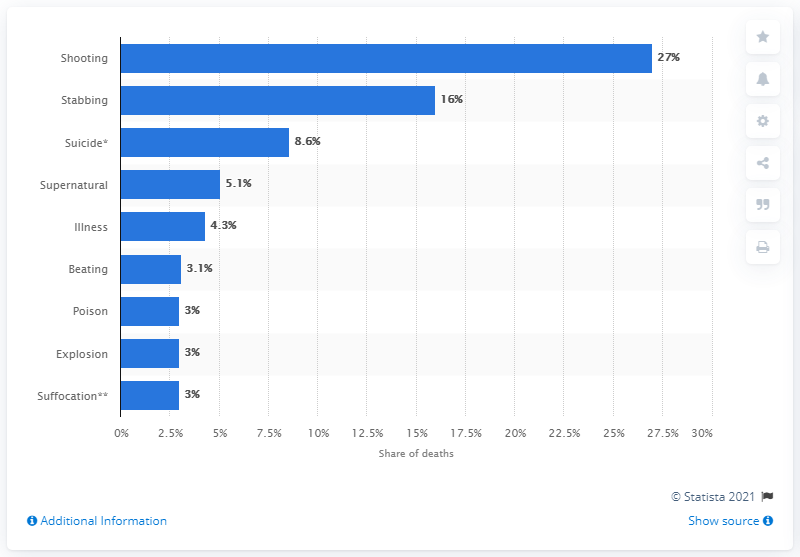Highlight a few significant elements in this photo. Shooting is the leading cause of death in the chart. There are four causes that currently have over 5% share. 